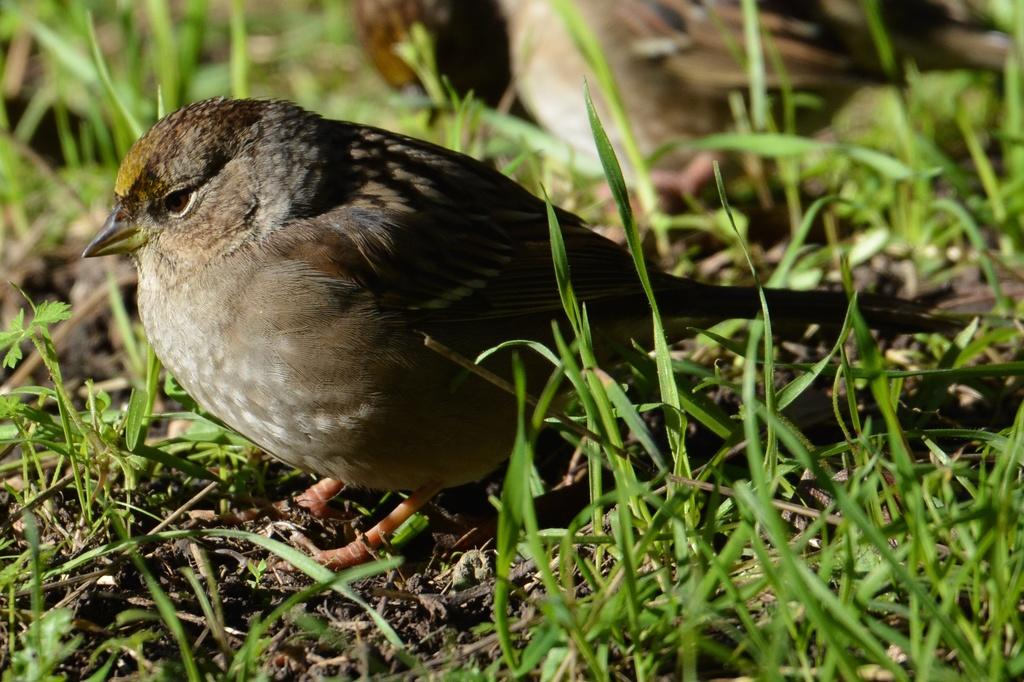What type of animal can be seen in the image? There is a bird in the image. Where is the bird located? The bird is on the land. What type of vegetation is visible in the image? There is grass visible in the image. What type of yak can be seen grazing on the grass in the image? There is no yak present in the image; it features a bird on the land. Can you tell me how many needles are scattered around the bird in the image? There are no needles present in the image; it features a bird on the land with grass visible. 